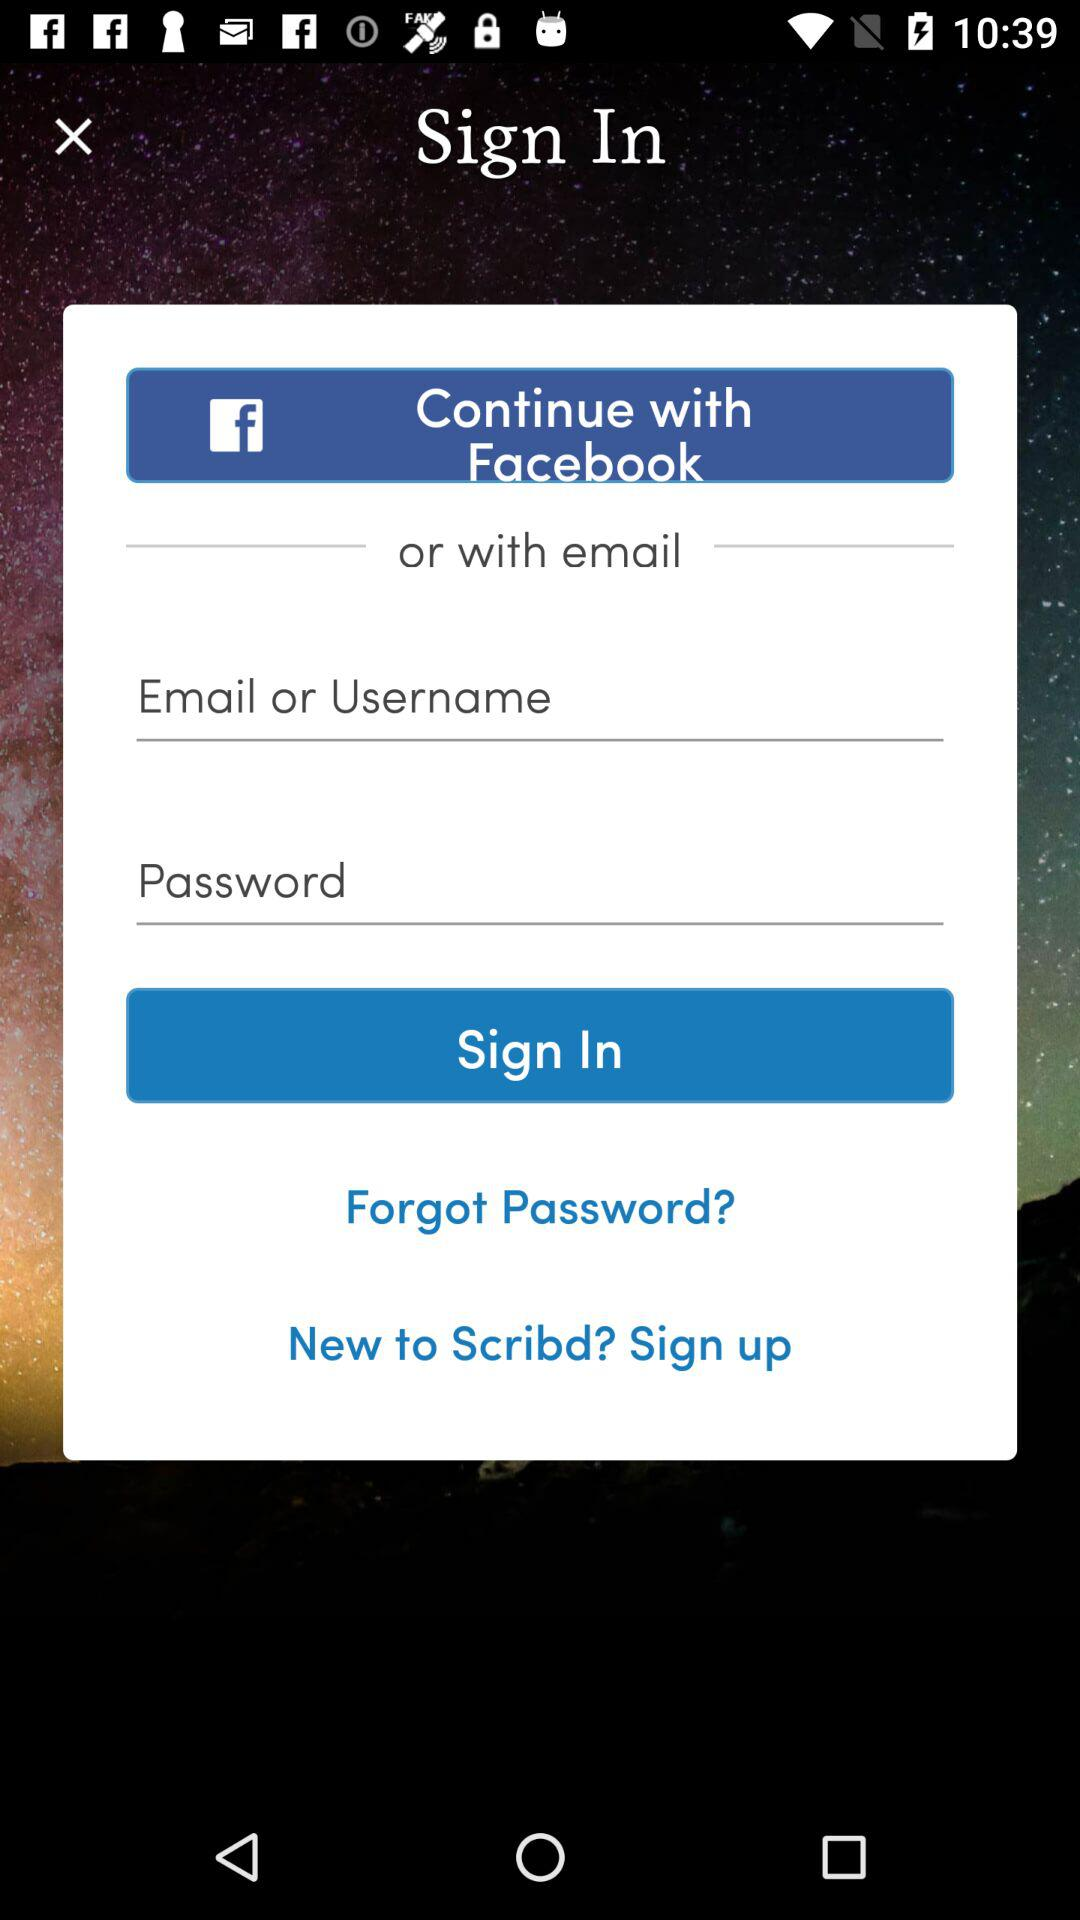Through what account can we log in? You can log in through "Facebook" or "email". 